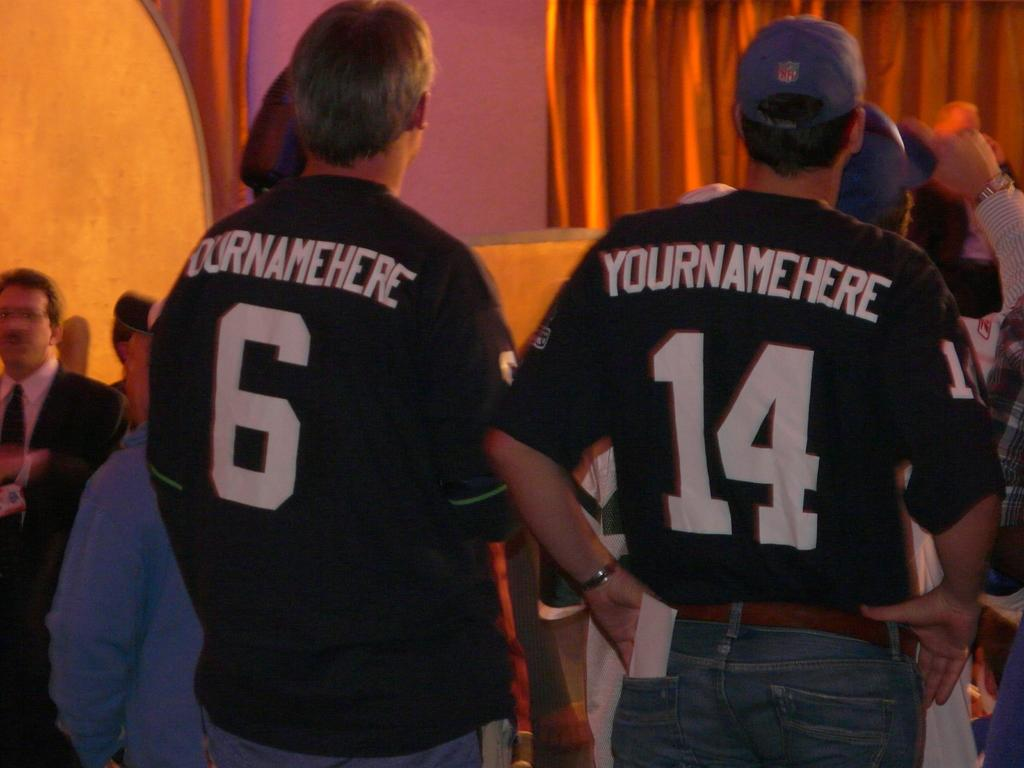<image>
Provide a brief description of the given image. two men are wearing Yournamehere shirts numbered 6 and 14 